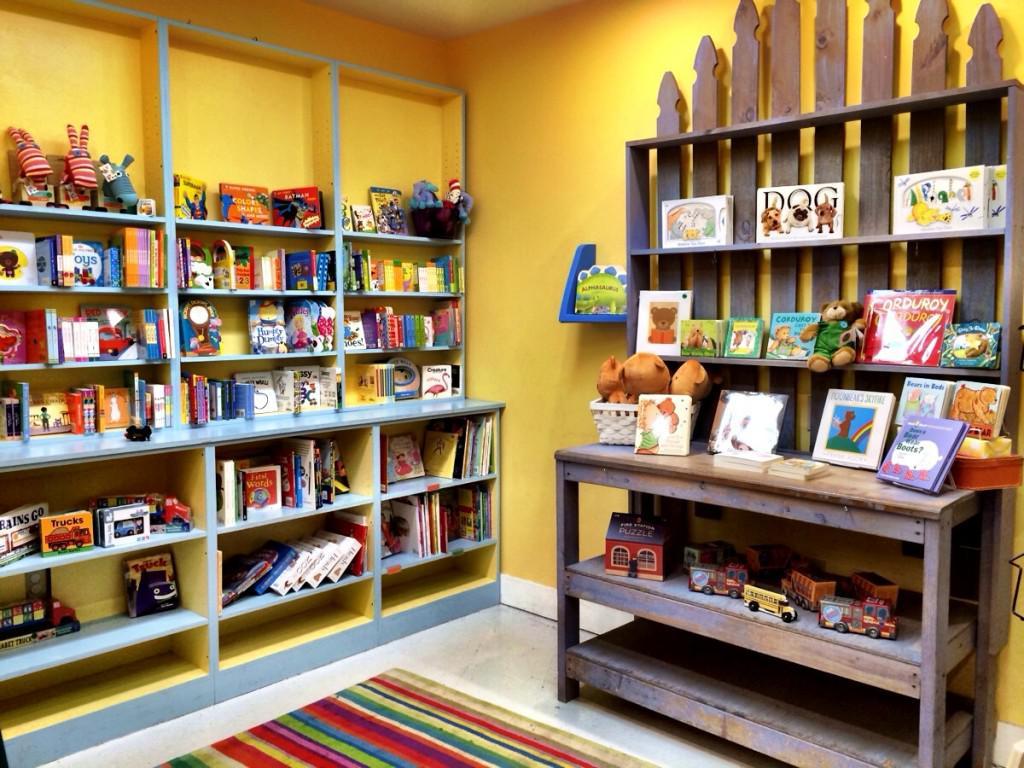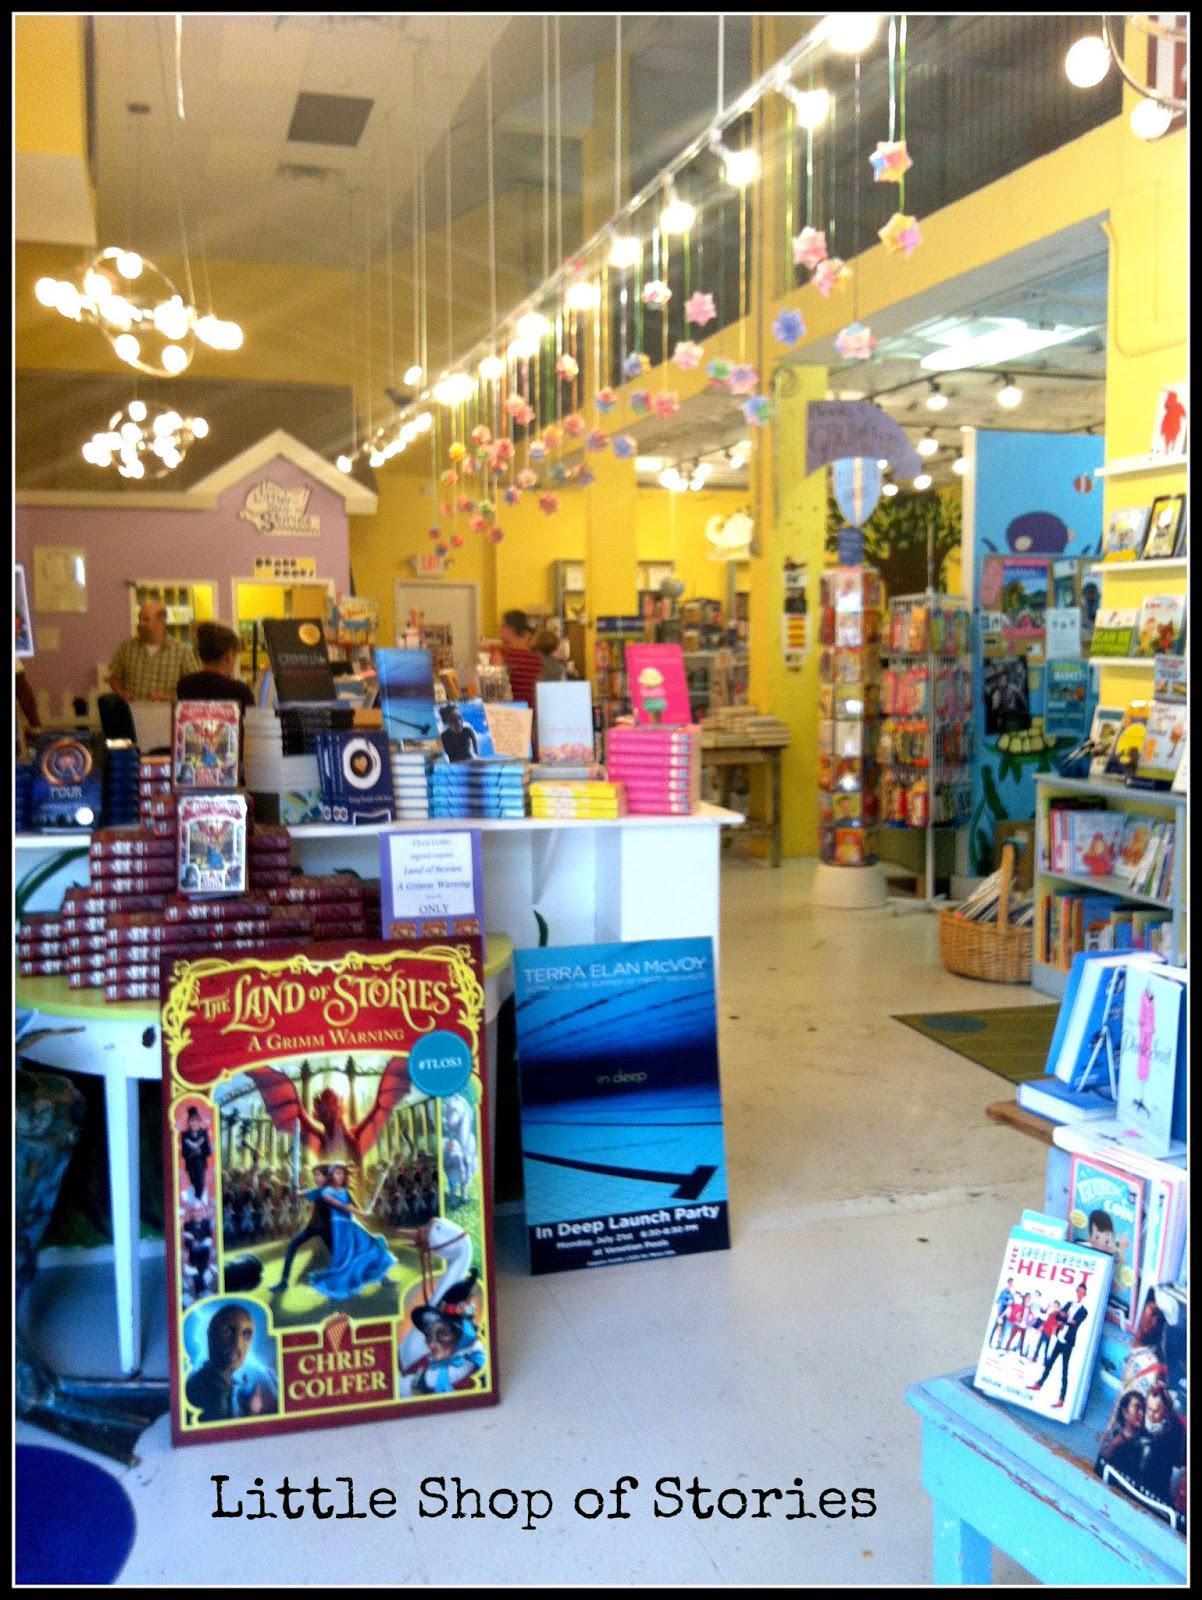The first image is the image on the left, the second image is the image on the right. For the images displayed, is the sentence "In at least one image there is a male child looking at yellow painted walls in the bookstore." factually correct? Answer yes or no. No. The first image is the image on the left, the second image is the image on the right. For the images displayed, is the sentence "One image shows a back-turned person standing in front of shelves at the right of the scene, and the other image includes at least one person sitting with a leg extended on the floor and back to the right." factually correct? Answer yes or no. No. 